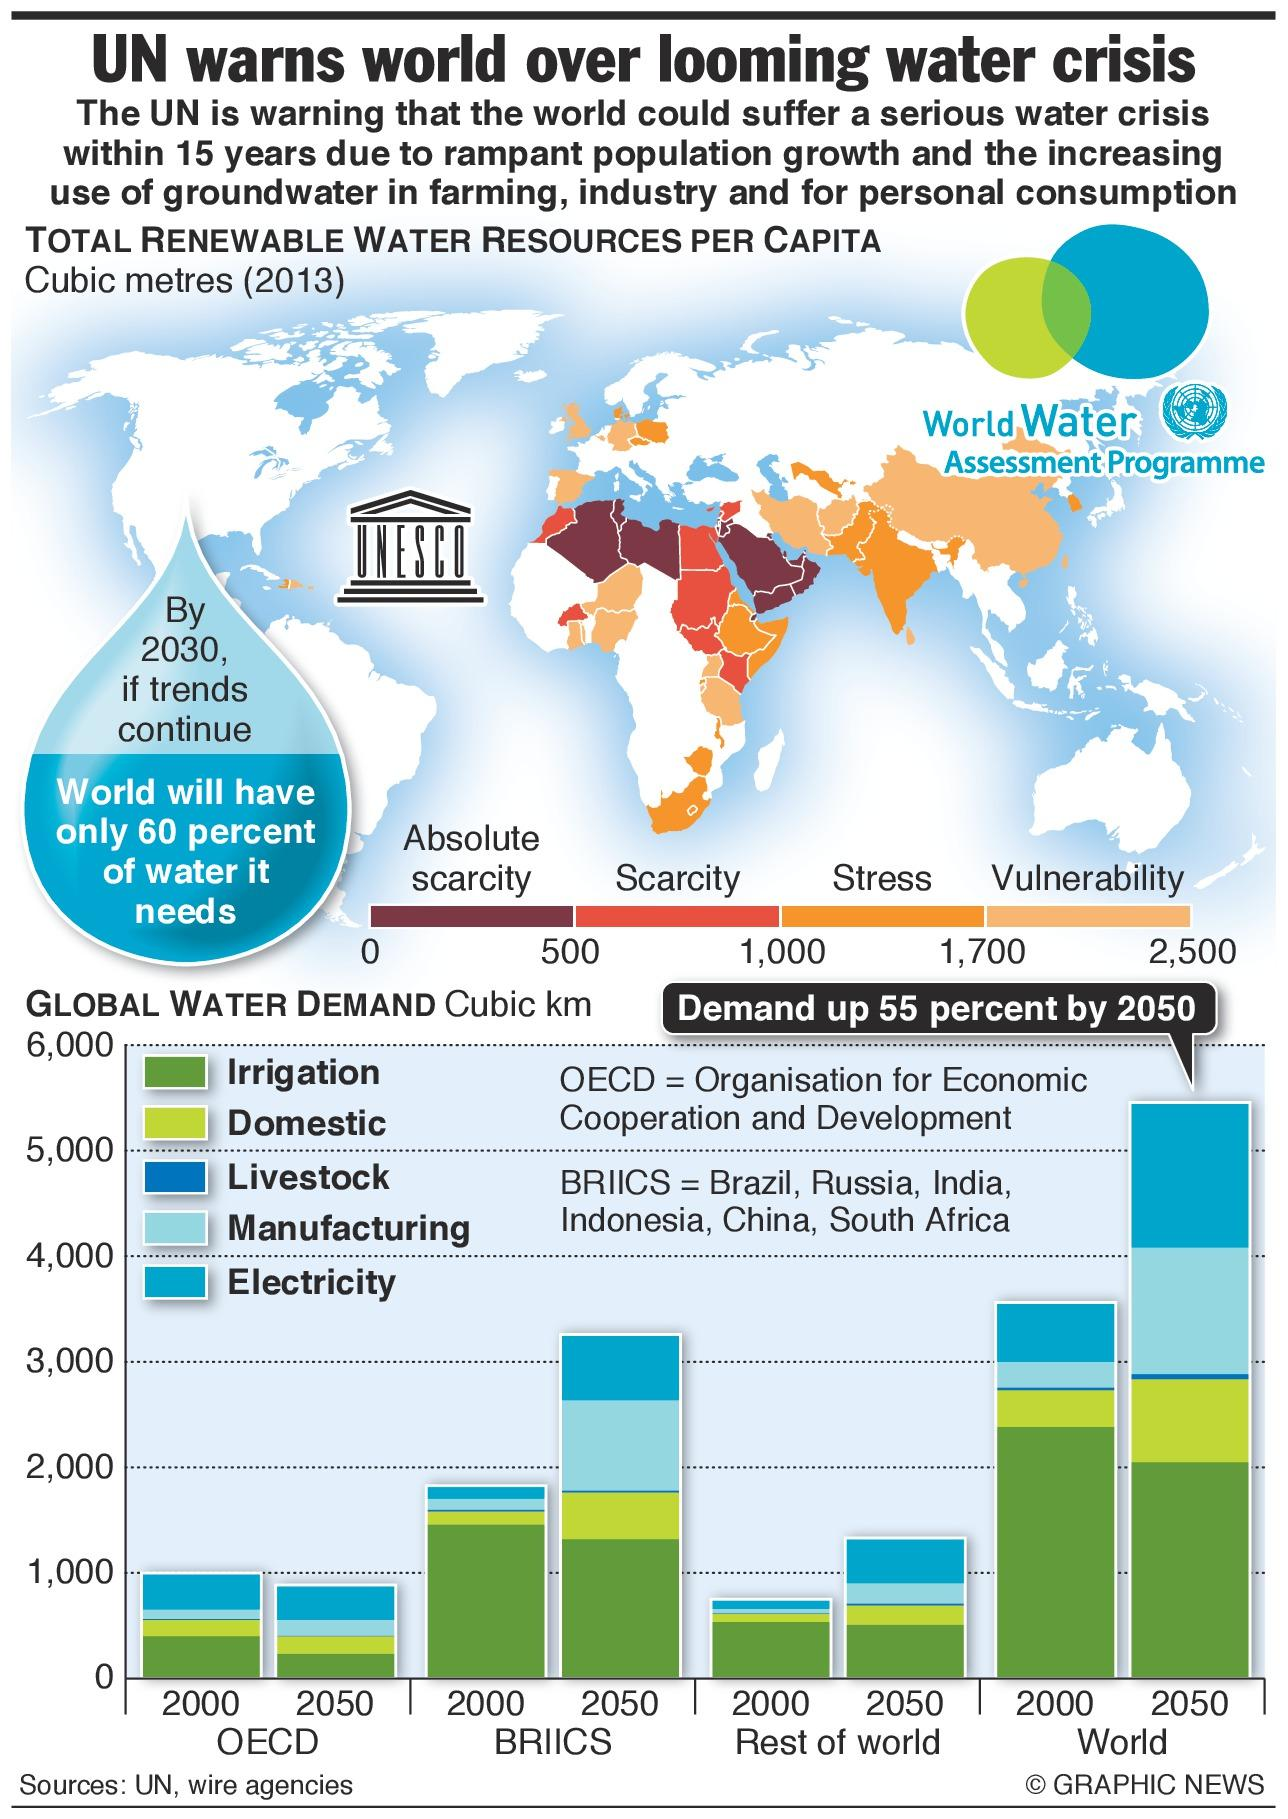Indicate a few pertinent items in this graphic. According to estimates, three countries in the Northern region of Africa are at risk of facing absolute scarcity of water in the near future. Asia has a larger area that is vulnerable to facing a water crisis compared to Europe, according to recent reports. 